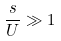<formula> <loc_0><loc_0><loc_500><loc_500>\frac { s } { U } \gg 1</formula> 